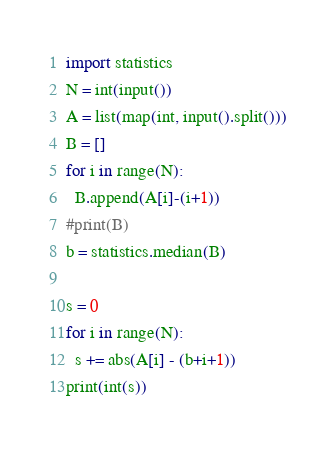Convert code to text. <code><loc_0><loc_0><loc_500><loc_500><_Python_>import statistics
N = int(input())
A = list(map(int, input().split()))
B = []
for i in range(N):
  B.append(A[i]-(i+1))
#print(B)
b = statistics.median(B)

s = 0
for i in range(N):
  s += abs(A[i] - (b+i+1))
print(int(s))
</code> 